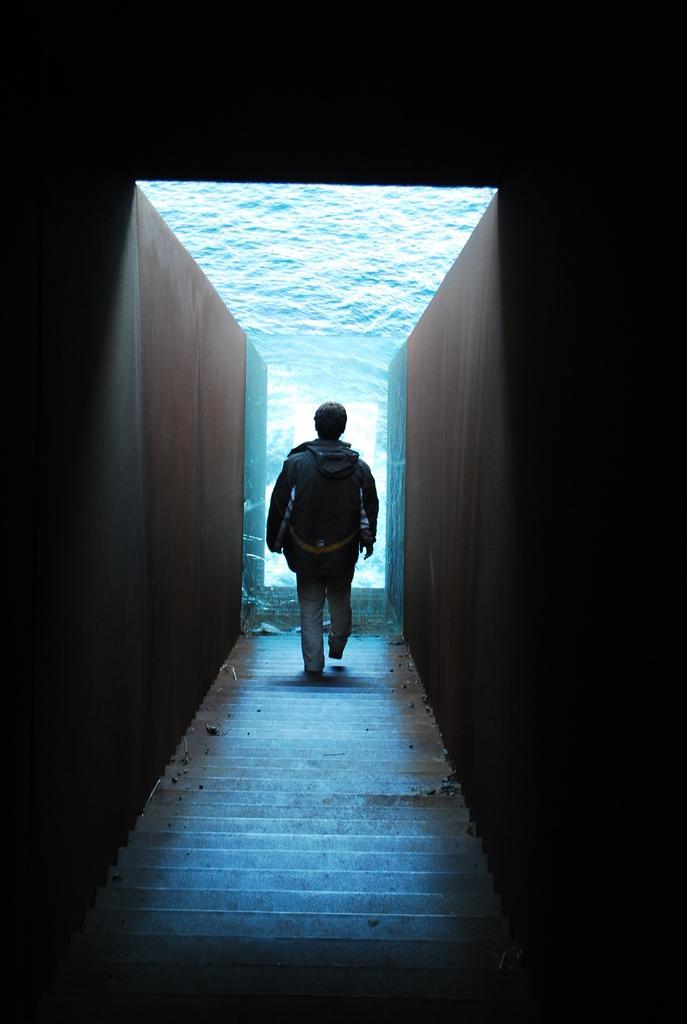Describe this image in one or two sentences. In this image a person is walking on the stairs. On both sides of stairs there is wall. This person is carrying a bag. 